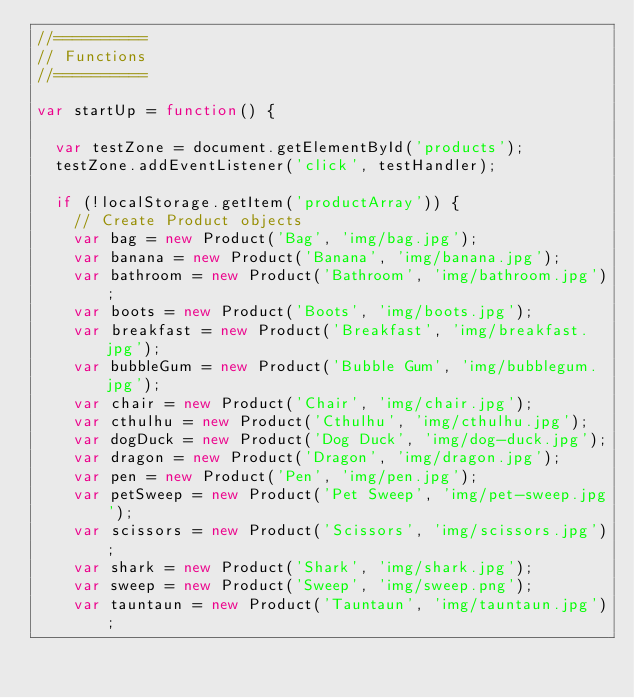Convert code to text. <code><loc_0><loc_0><loc_500><loc_500><_JavaScript_>//==========
// Functions
//==========

var startUp = function() {

  var testZone = document.getElementById('products');
  testZone.addEventListener('click', testHandler);

  if (!localStorage.getItem('productArray')) {
    // Create Product objects
    var bag = new Product('Bag', 'img/bag.jpg');
    var banana = new Product('Banana', 'img/banana.jpg');
    var bathroom = new Product('Bathroom', 'img/bathroom.jpg');
    var boots = new Product('Boots', 'img/boots.jpg');
    var breakfast = new Product('Breakfast', 'img/breakfast.jpg');
    var bubbleGum = new Product('Bubble Gum', 'img/bubblegum.jpg');
    var chair = new Product('Chair', 'img/chair.jpg');
    var cthulhu = new Product('Cthulhu', 'img/cthulhu.jpg');
    var dogDuck = new Product('Dog Duck', 'img/dog-duck.jpg');
    var dragon = new Product('Dragon', 'img/dragon.jpg');
    var pen = new Product('Pen', 'img/pen.jpg');
    var petSweep = new Product('Pet Sweep', 'img/pet-sweep.jpg');
    var scissors = new Product('Scissors', 'img/scissors.jpg');
    var shark = new Product('Shark', 'img/shark.jpg');
    var sweep = new Product('Sweep', 'img/sweep.png');
    var tauntaun = new Product('Tauntaun', 'img/tauntaun.jpg');</code> 